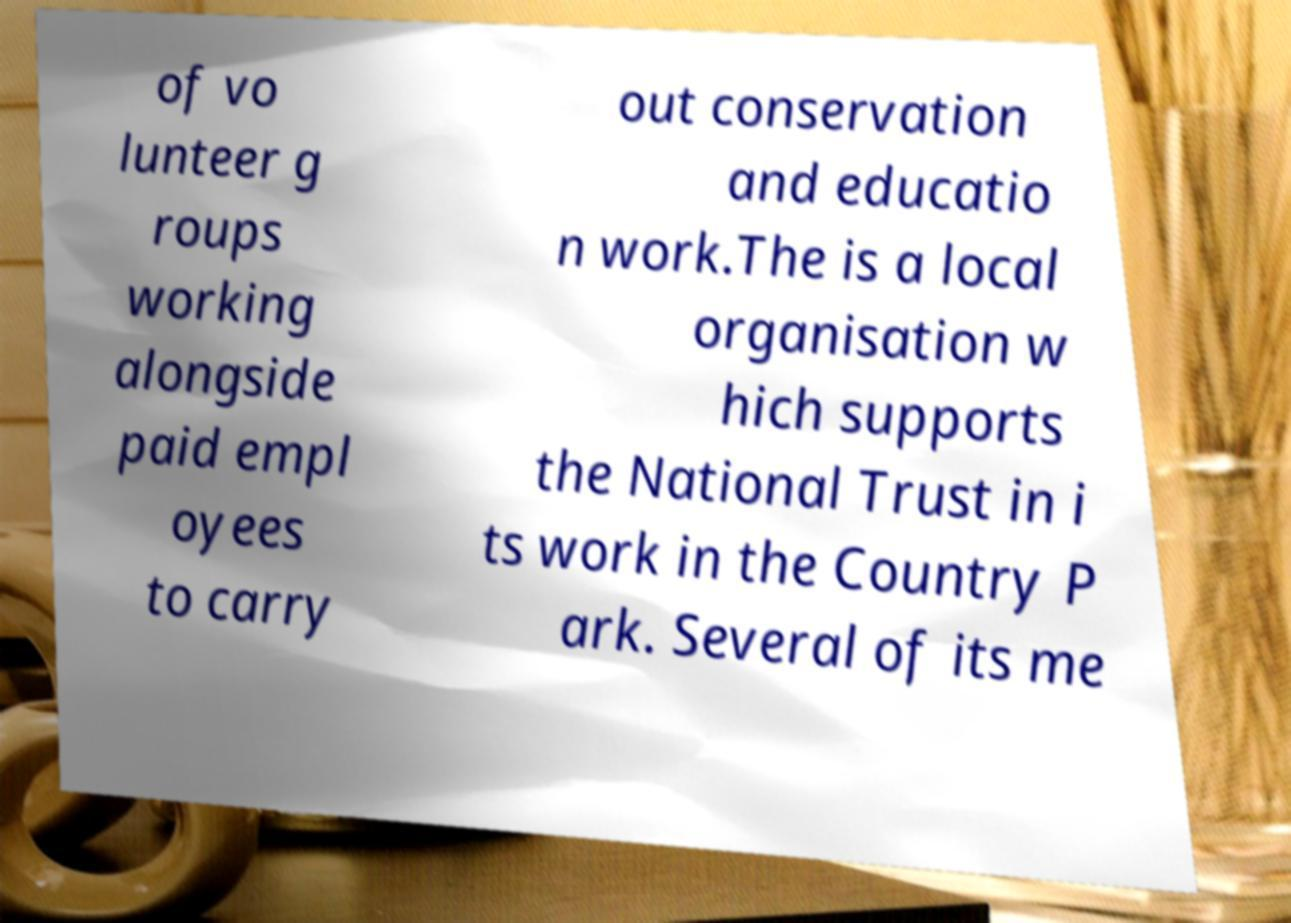Could you extract and type out the text from this image? of vo lunteer g roups working alongside paid empl oyees to carry out conservation and educatio n work.The is a local organisation w hich supports the National Trust in i ts work in the Country P ark. Several of its me 